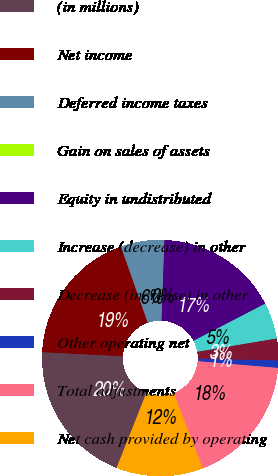Convert chart to OTSL. <chart><loc_0><loc_0><loc_500><loc_500><pie_chart><fcel>(in millions)<fcel>Net income<fcel>Deferred income taxes<fcel>Gain on sales of assets<fcel>Equity in undistributed<fcel>Increase (decrease) in other<fcel>Decrease (increase) in other<fcel>Other operating net<fcel>Total adjustments<fcel>Net cash provided by operating<nl><fcel>19.79%<fcel>18.8%<fcel>5.95%<fcel>0.01%<fcel>16.82%<fcel>4.96%<fcel>2.98%<fcel>1.0%<fcel>17.81%<fcel>11.88%<nl></chart> 